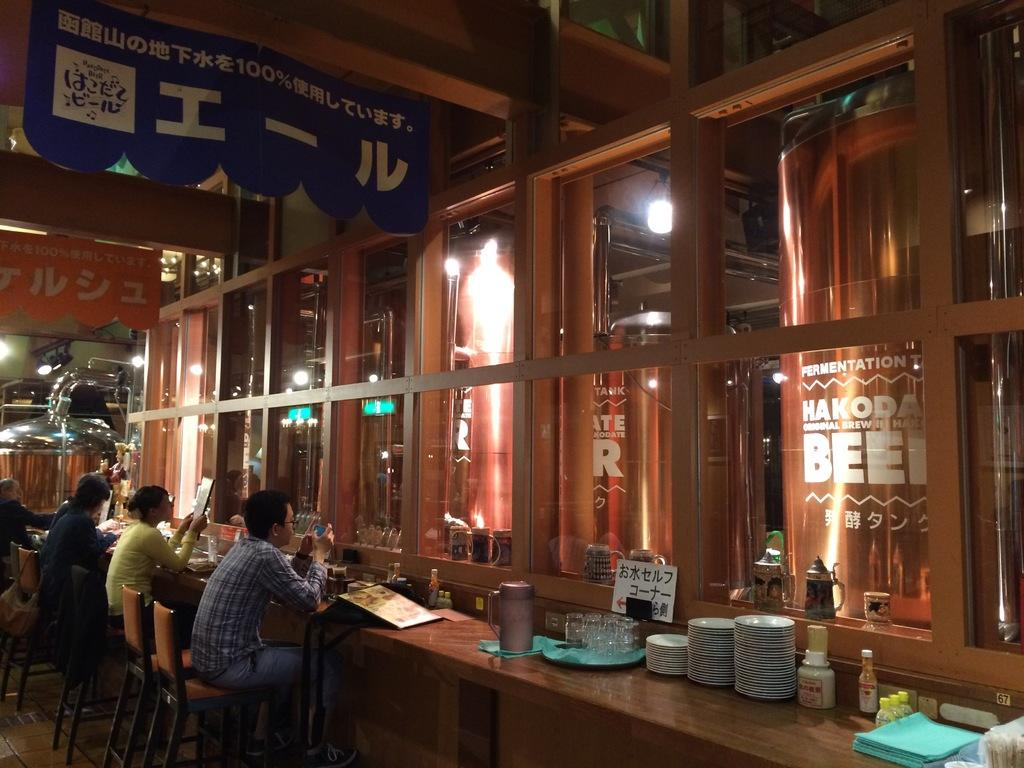What are the people in the image doing? The people in the image are sitting on chairs at a table. What objects can be seen on the table? There are plates, bottles, jugs, and glasses on the table. What type of door is visible in the image? There is a glass door in the image. What is covering the table? There is a cloth on the table. Can you see a worm crawling on the table in the image? No, there is no worm present in the image. 